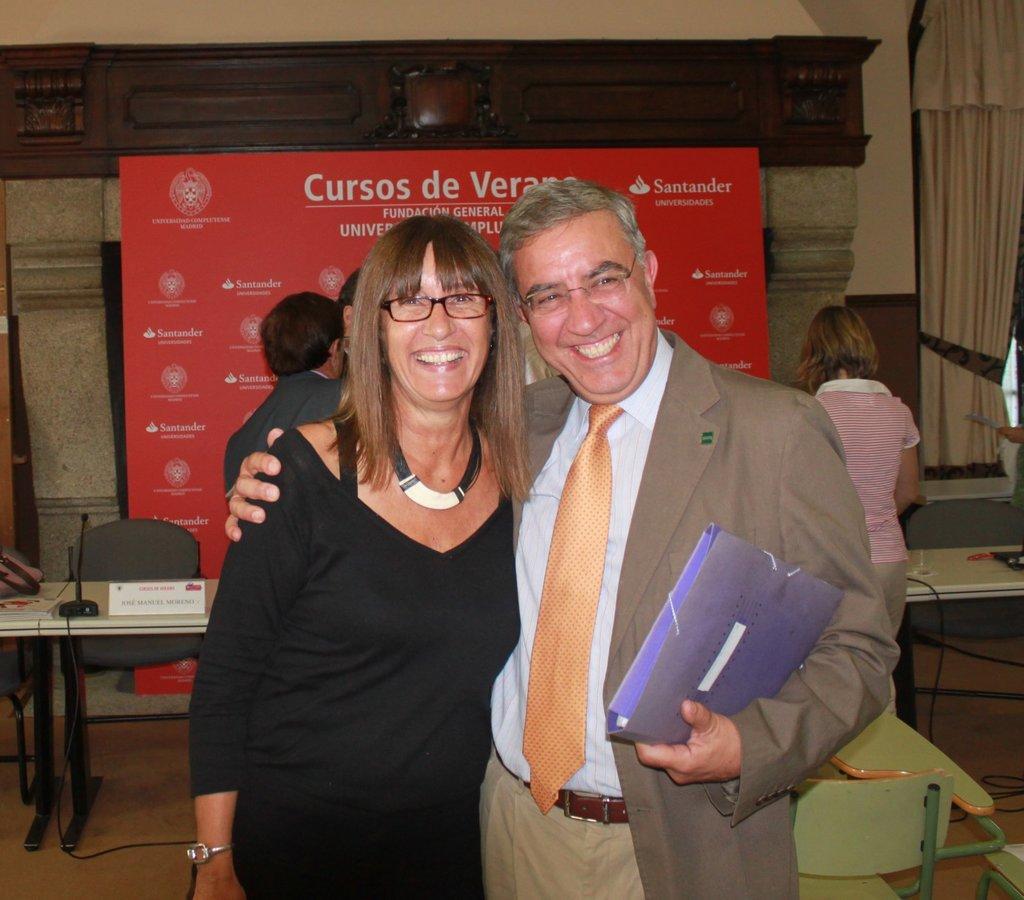In one or two sentences, can you explain what this image depicts? In this image in the center on the right side there is one man who is standing and smiling and he is holding a file. On the left side there is one woman who is standing and smiling. On the background there is wall, on the right side there is one curtain and one board is there and in the center there is one table on that table there are some miles and name plates and some wires are there. 